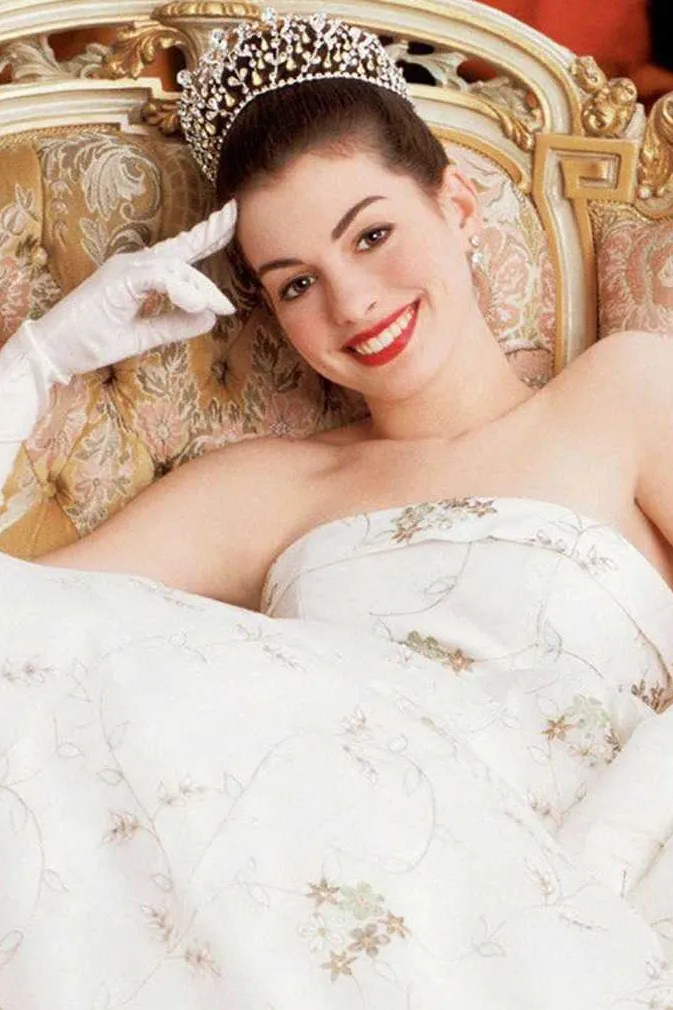Explain the visual content of the image in great detail.
 In this image, we see the talented actress Anne Hathaway, embodying her character Mia Thermopolis from the movie "The Princess Diaries". She is elegantly dressed in a white strapless gown adorned with floral embroidery, and a sparkling diamond tiara crowns her head. Her hair is styled in a sophisticated updo, adding to her regal appearance. She is reclining comfortably on an ornate sofa, its gold and beige hues contrasting beautifully with her white attire. A white gloved hand rests lightly on the armrest of the sofa. Her face is lit up with a radiant smile, capturing the joyful essence of her character. 